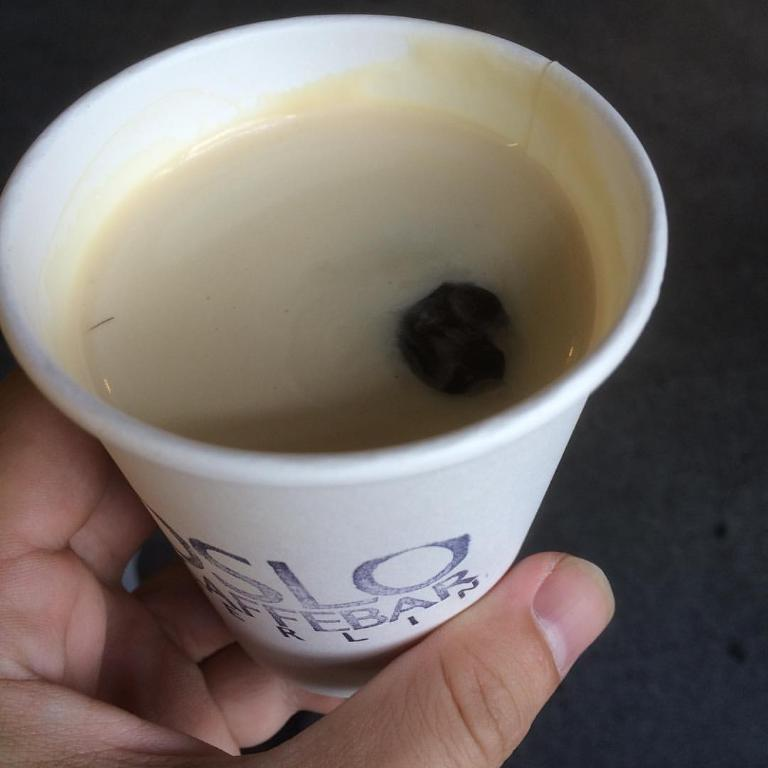What can be seen in the person's hand in the image? There is a cup of drink in the person's hand. Can you describe the cup of drink in the person's hand? The cup of drink is held by the person's hand. What type of adjustment is being made to the suit in the image? There is no suit or adjustment present in the image; it only features a person's hand holding a cup of drink. 